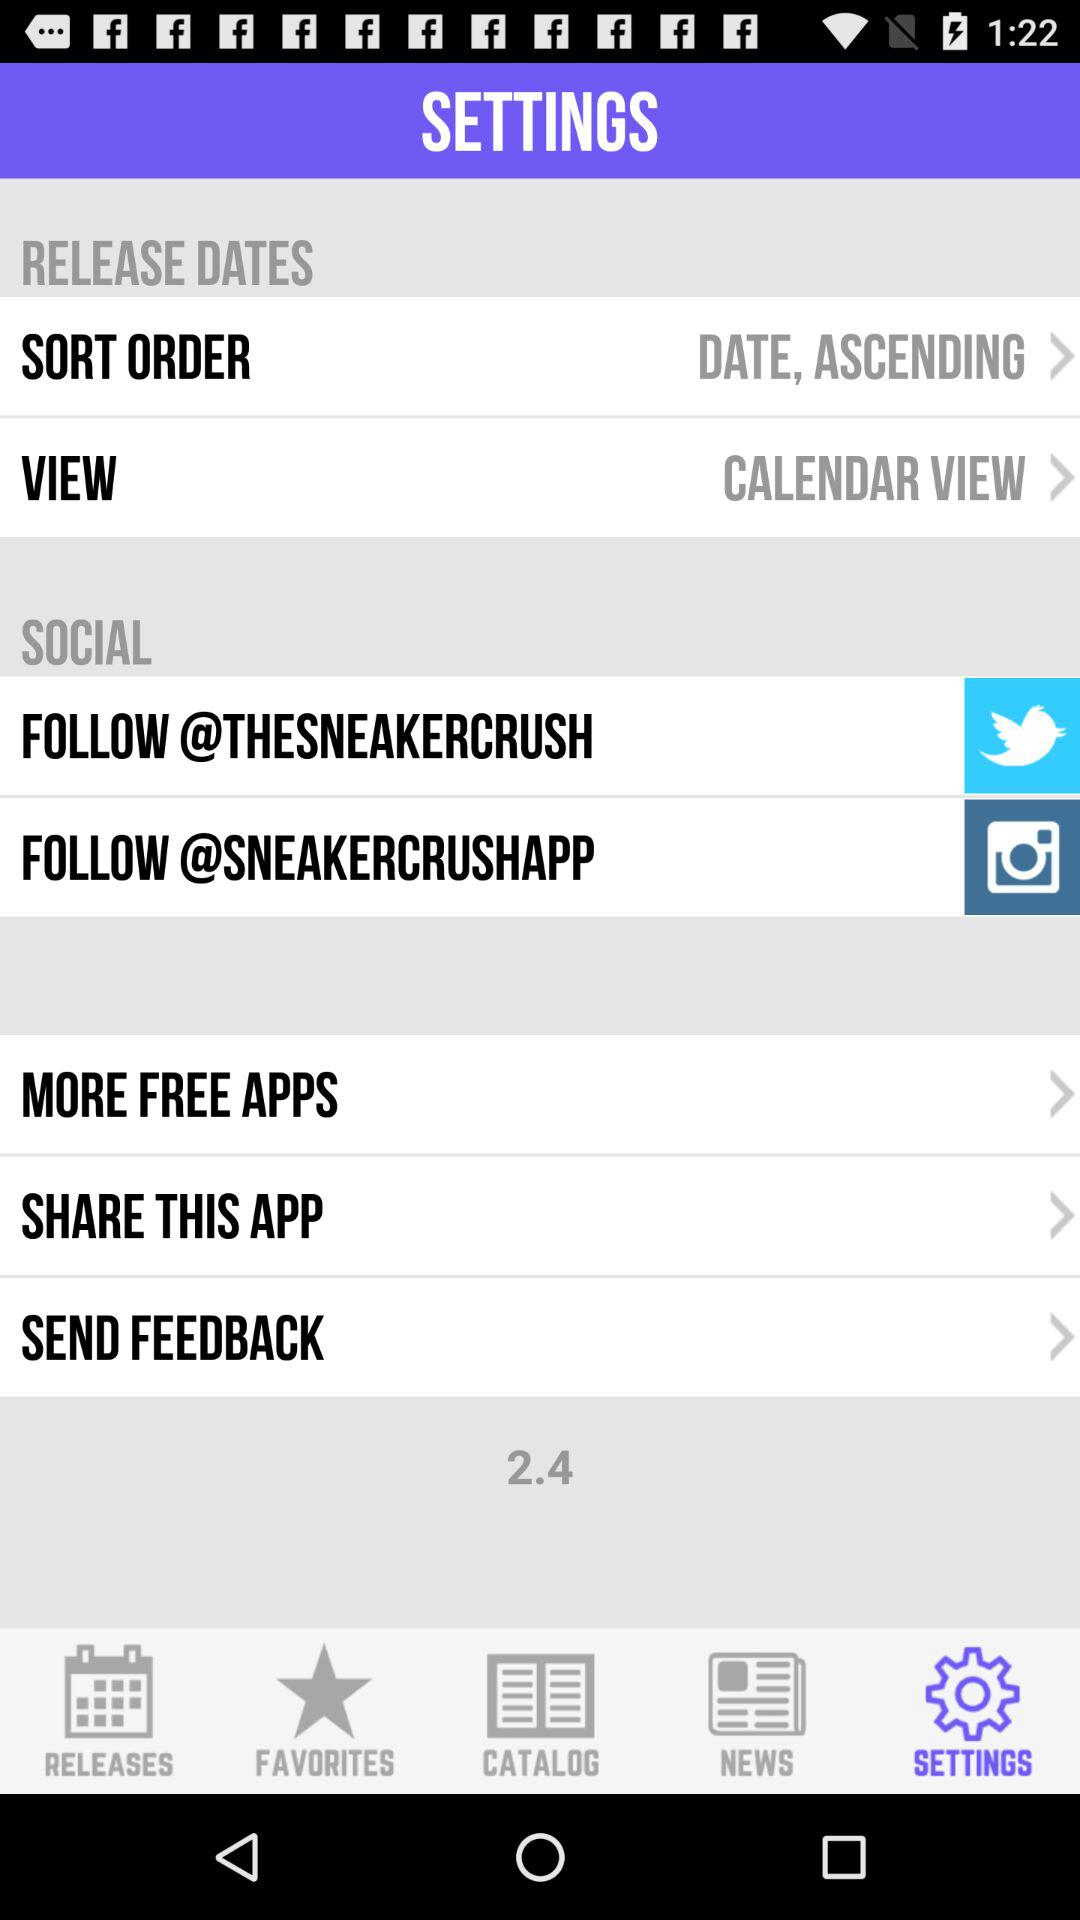Which social media applications can I use to follow? You can use "Twitter" and "Instagram" to follow. 